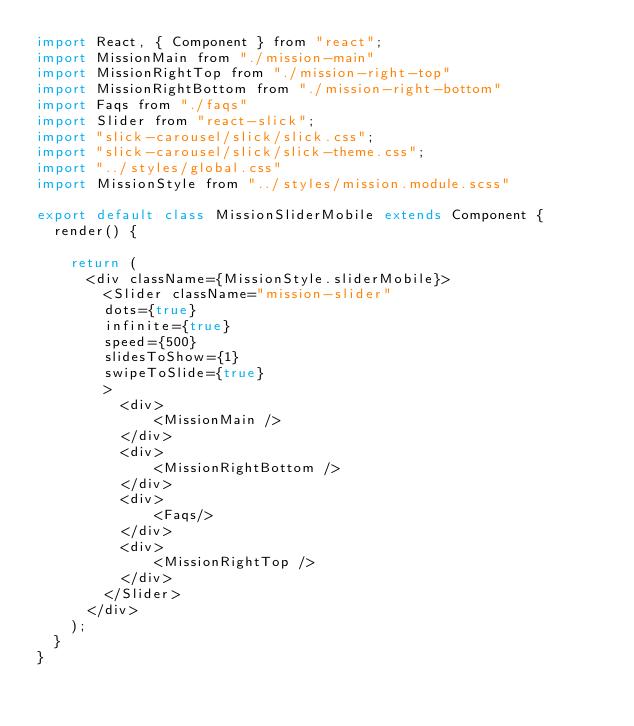<code> <loc_0><loc_0><loc_500><loc_500><_JavaScript_>import React, { Component } from "react";
import MissionMain from "./mission-main"
import MissionRightTop from "./mission-right-top"
import MissionRightBottom from "./mission-right-bottom"
import Faqs from "./faqs"
import Slider from "react-slick";
import "slick-carousel/slick/slick.css";
import "slick-carousel/slick/slick-theme.css";
import "../styles/global.css"
import MissionStyle from "../styles/mission.module.scss"

export default class MissionSliderMobile extends Component {
  render() {
    
    return (
      <div className={MissionStyle.sliderMobile}>
        <Slider className="mission-slider"
        dots={true}
        infinite={true}
        speed={500}
        slidesToShow={1}
        swipeToSlide={true}
        >
          <div>
              <MissionMain />
          </div>
          <div>
              <MissionRightBottom />
          </div>
          <div>
              <Faqs/>
          </div>
          <div>
              <MissionRightTop />
          </div>
        </Slider>
      </div>
    );
  }
}
</code> 